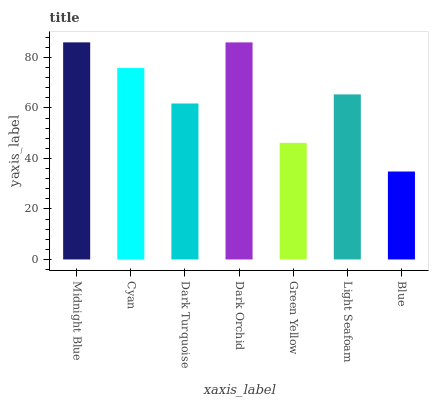Is Blue the minimum?
Answer yes or no. Yes. Is Midnight Blue the maximum?
Answer yes or no. Yes. Is Cyan the minimum?
Answer yes or no. No. Is Cyan the maximum?
Answer yes or no. No. Is Midnight Blue greater than Cyan?
Answer yes or no. Yes. Is Cyan less than Midnight Blue?
Answer yes or no. Yes. Is Cyan greater than Midnight Blue?
Answer yes or no. No. Is Midnight Blue less than Cyan?
Answer yes or no. No. Is Light Seafoam the high median?
Answer yes or no. Yes. Is Light Seafoam the low median?
Answer yes or no. Yes. Is Cyan the high median?
Answer yes or no. No. Is Blue the low median?
Answer yes or no. No. 